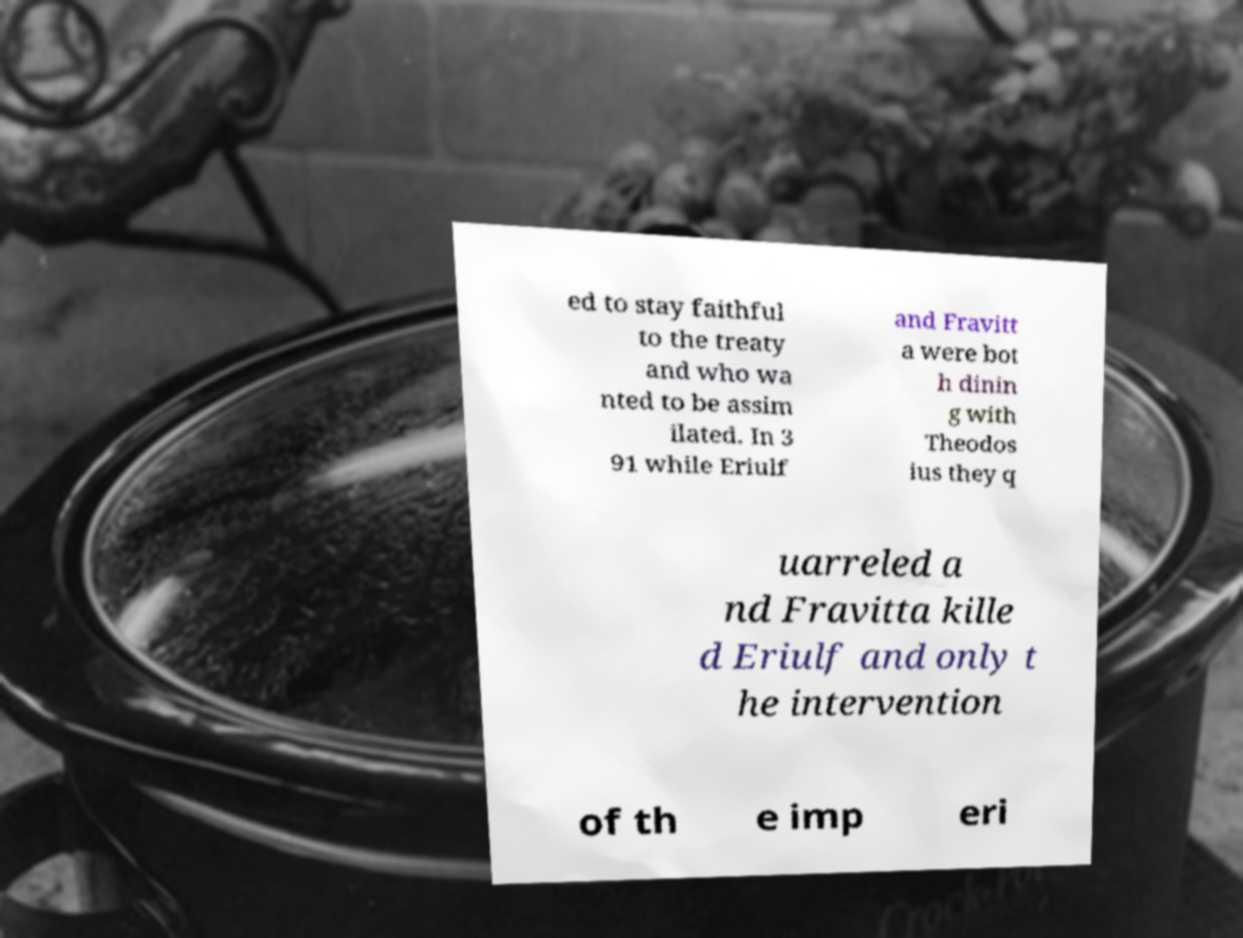I need the written content from this picture converted into text. Can you do that? ed to stay faithful to the treaty and who wa nted to be assim ilated. In 3 91 while Eriulf and Fravitt a were bot h dinin g with Theodos ius they q uarreled a nd Fravitta kille d Eriulf and only t he intervention of th e imp eri 